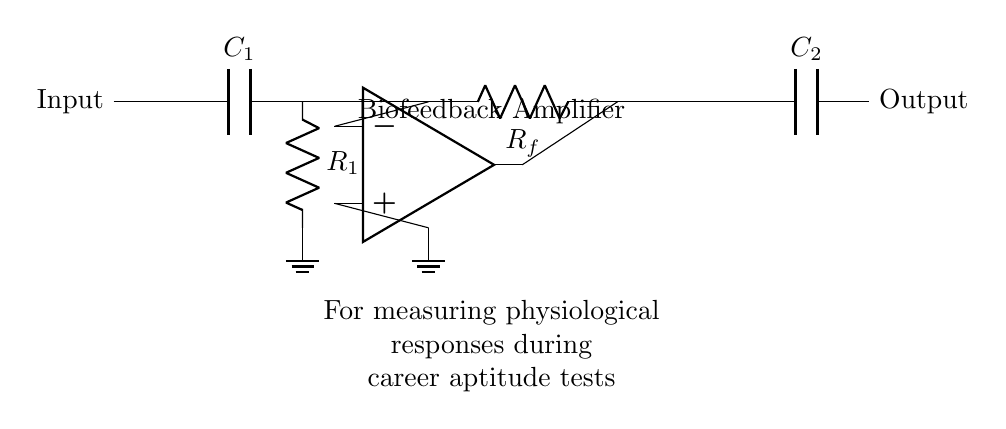What is the purpose of the capacitor C1? Capacitor C1 is used as a coupling capacitor that allows AC signals to pass while blocking DC components, ensuring only the desired physiological signals are amplified.
Answer: Coupling What type of circuit is this? This circuit is an operational amplifier circuit specifically designed as a biofeedback amplifier.
Answer: Amplifier What is the role of the resistor Rf in this circuit? Resistor Rf is part of the feedback network that determines the gain of the operational amplifier, allowing the output voltage to be controlled based on the input signal.
Answer: Gain How many operational amplifiers are present in this circuit? There is one operational amplifier (op amp) in the circuit diagram, indicated by the op amp symbol.
Answer: One What do the symbols at the top and bottom of the op amp represent? The top symbol represents the non-inverting input, and the bottom symbol represents the inverting input of the operational amplifier, which are used to compare the input signals.
Answer: Inputs What is the output of this biofeedback amplifier connected to? The output of the biofeedback amplifier is connected to capacitor C2, which is used to further process or filter the output signal before it is fed to the next stage.
Answer: C2 